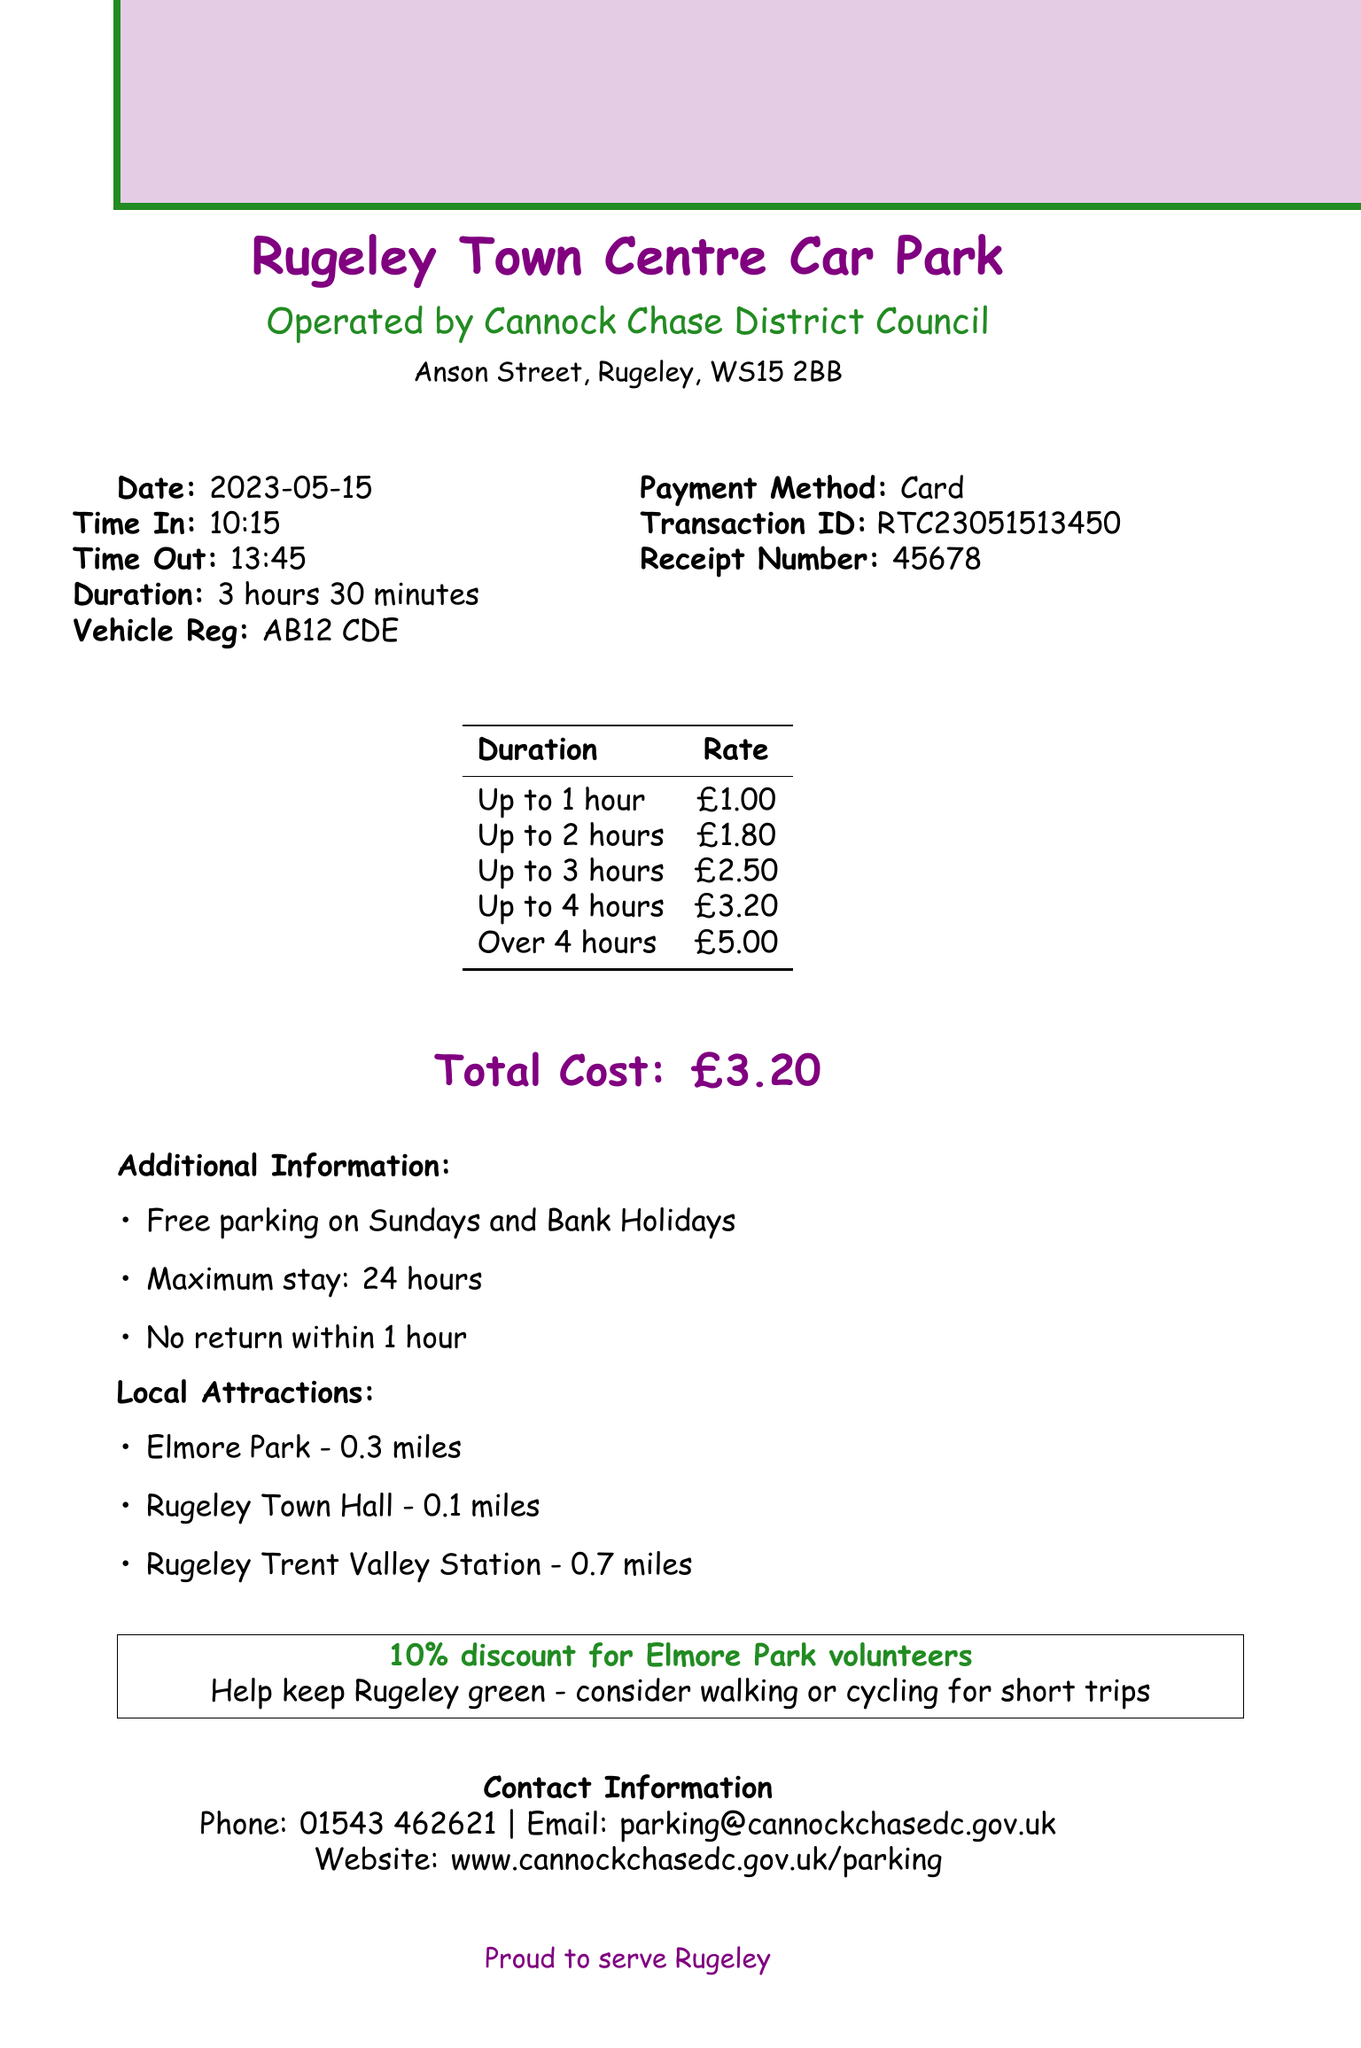What is the name of the car park? The car park is referred to in the document by its official name.
Answer: Rugeley Town Centre Car Park Who operates the car park? The operator is mentioned clearly at the top of the document.
Answer: Cannock Chase District Council What was the duration of parking? The document explicitly states how long the vehicle was parked.
Answer: 3 hours 30 minutes What is the total cost of parking? The total cost is clearly indicated in a highlighted section of the document.
Answer: £3.20 How much is free parking offered? The document mentions specific days when parking is free.
Answer: Sundays and Bank Holidays What is the payment method listed? The transaction details show the method used for payment.
Answer: Card What is the vehicle registration number? The vehicle registration is specifically provided within the document's details.
Answer: AB12 CDE How far is Elmore Park from the car park? The distance to local attractions is listed in the document, specifically for Elmore Park.
Answer: 0.3 miles Is there a discount for volunteers? Additional information regarding discounts is provided in a specific section of the document.
Answer: 10% discount for Elmore Park volunteers 